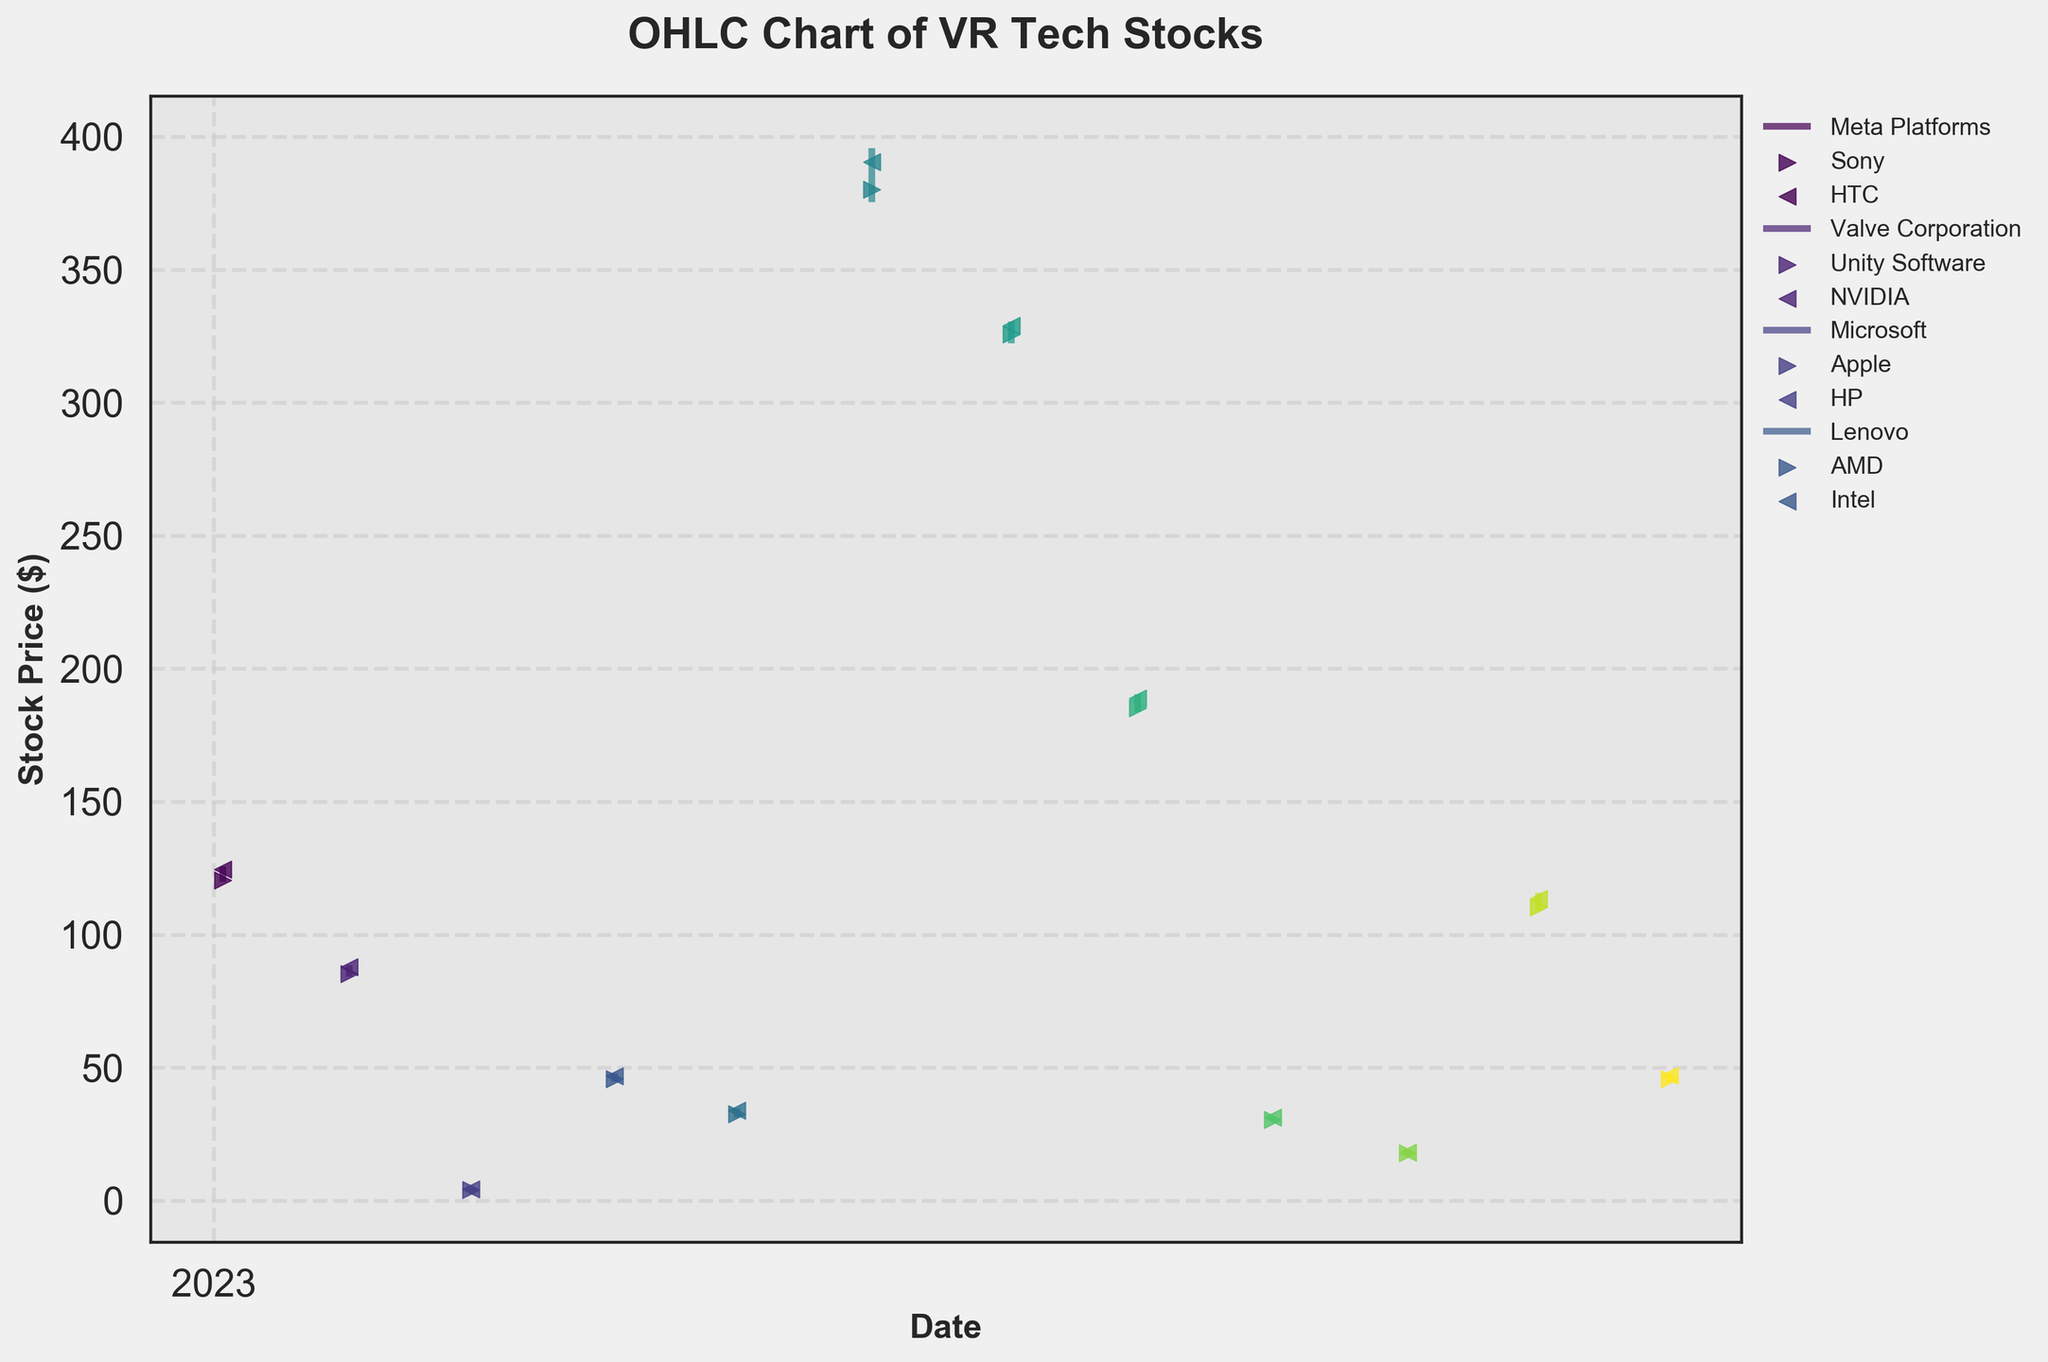What is the title of the figure? The title is typically found at the top of the figure and is bold and larger compared to other text. It provides a summary of the content.
Answer: OHLC Chart of VR Tech Stocks What is the highest closing price and which company does it belong to? By observing the rightward triangle markers (representing the closing prices) in the figure, we can see which marker is at the highest position on the y-axis. The company with the highest closing price is associated with this marker.
Answer: NVIDIA, $390.45 Which company has the lowest trading volume in the figure? The trading volume is often represented elsewhere in the figure, but if it’s part of the data, finding the company with the smallest volume number would answer this. Here, we look at all volume values and find the smallest one.
Answer: Valve Corporation, 2,345,678 Which two companies have the closest opening prices in the year? Check the leftward triangle markers (representing the opening prices) for each company and identify which two are closest in their vertical position (y-axis value).
Answer: Sony and AMD How many companies' closing prices are above $100? Count the number of rightward triangle markers that are positioned above the $100 mark on the y-axis.
Answer: Five companies (Meta Platforms, NVIDIA, Microsoft, Apple, AMD) Which company saw the largest difference between its high and low prices, and what was that difference? Calculate the range (High - Low) for each company and compare them. Find the largest range.
Answer: NVIDIA, $20.33 Between which two consecutive months is the greatest increase in closing price observed? Compare the closing prices from month to month and find the difference between each pair of consecutive months. Identify the pair with the highest positive difference.
Answer: January (Meta Platforms) to February (Sony) Which company's stock had the highest high price and what was that value? Look for the company whose upward line (representing the high price) is the highest on the y-axis.
Answer: NVIDIA, $395.67 How many companies had their lowest price below $50 at any point? Count the number of companies whose downward line (representing the low price) dips below the $50 mark on the y-axis.
Answer: Five companies (Meta Platforms, Sony, HTC, Valve Corporation, Lenovo) What is the average opening price of all the companies combined? Add up all the opening prices and divide by the number of companies represented in the figure.
Answer: $135.12 